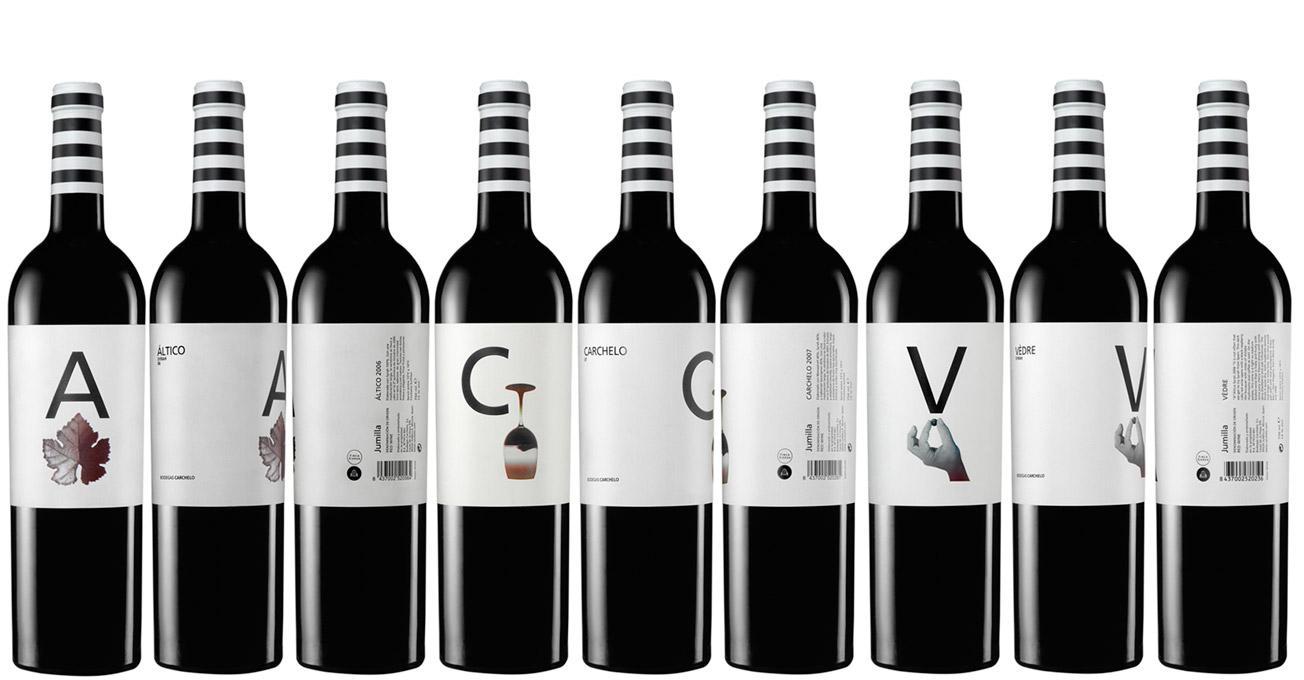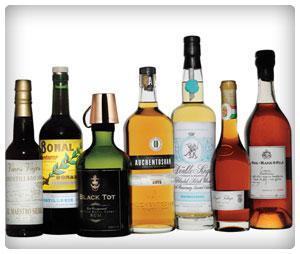The first image is the image on the left, the second image is the image on the right. For the images shown, is this caption "There are more bottles in the right image than in the left image." true? Answer yes or no. No. The first image is the image on the left, the second image is the image on the right. Evaluate the accuracy of this statement regarding the images: "There are no more than four bottles in one of the images.". Is it true? Answer yes or no. No. 